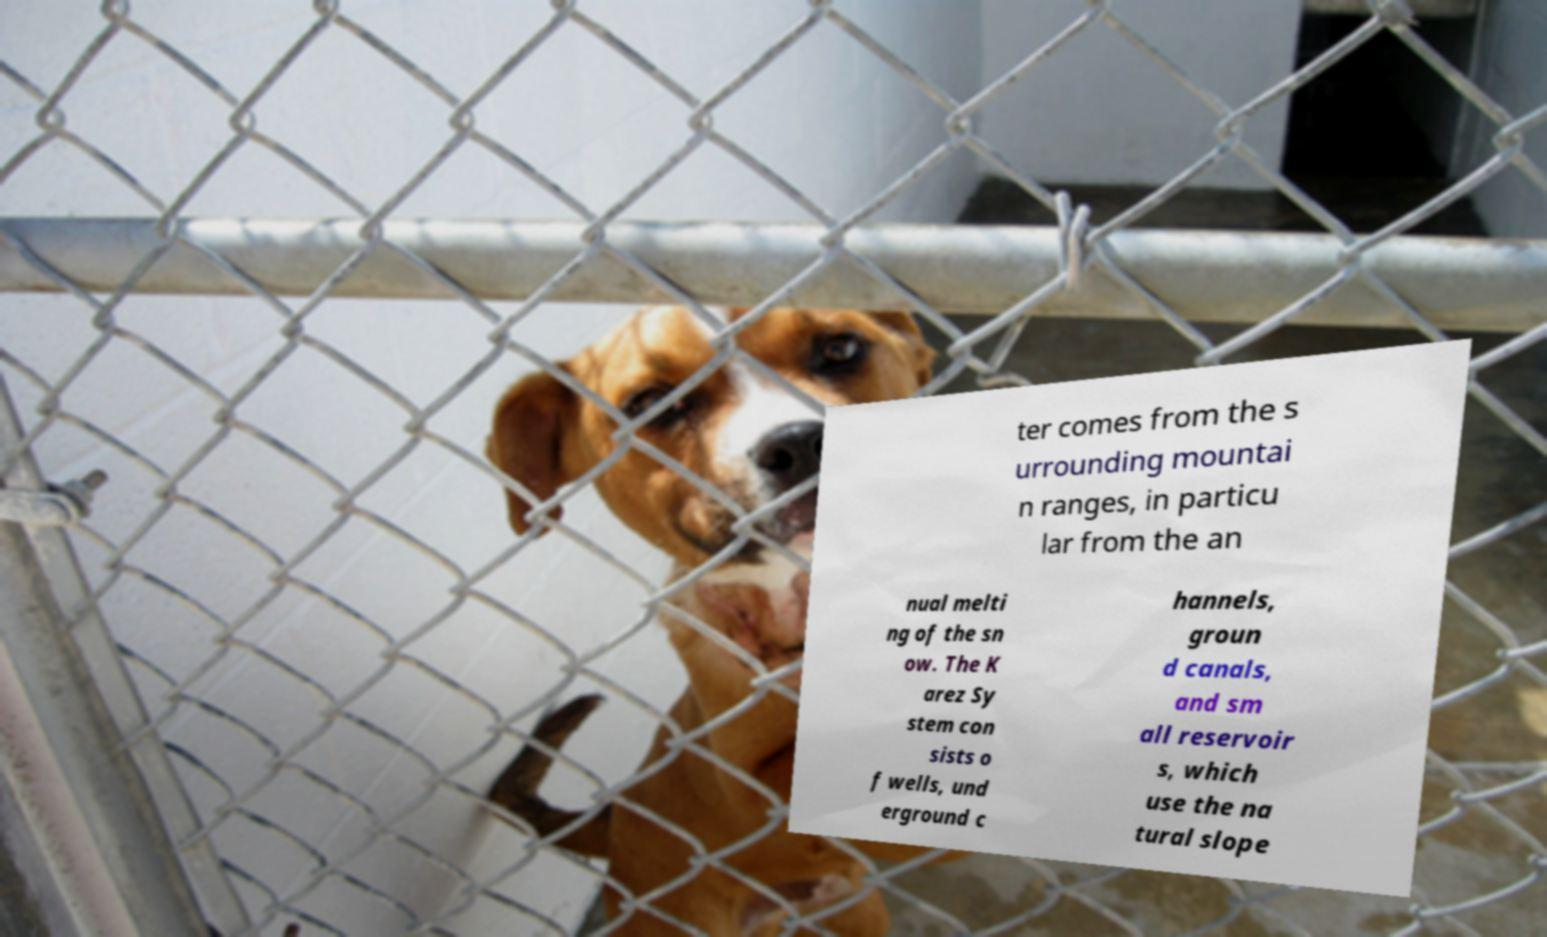Could you assist in decoding the text presented in this image and type it out clearly? ter comes from the s urrounding mountai n ranges, in particu lar from the an nual melti ng of the sn ow. The K arez Sy stem con sists o f wells, und erground c hannels, groun d canals, and sm all reservoir s, which use the na tural slope 